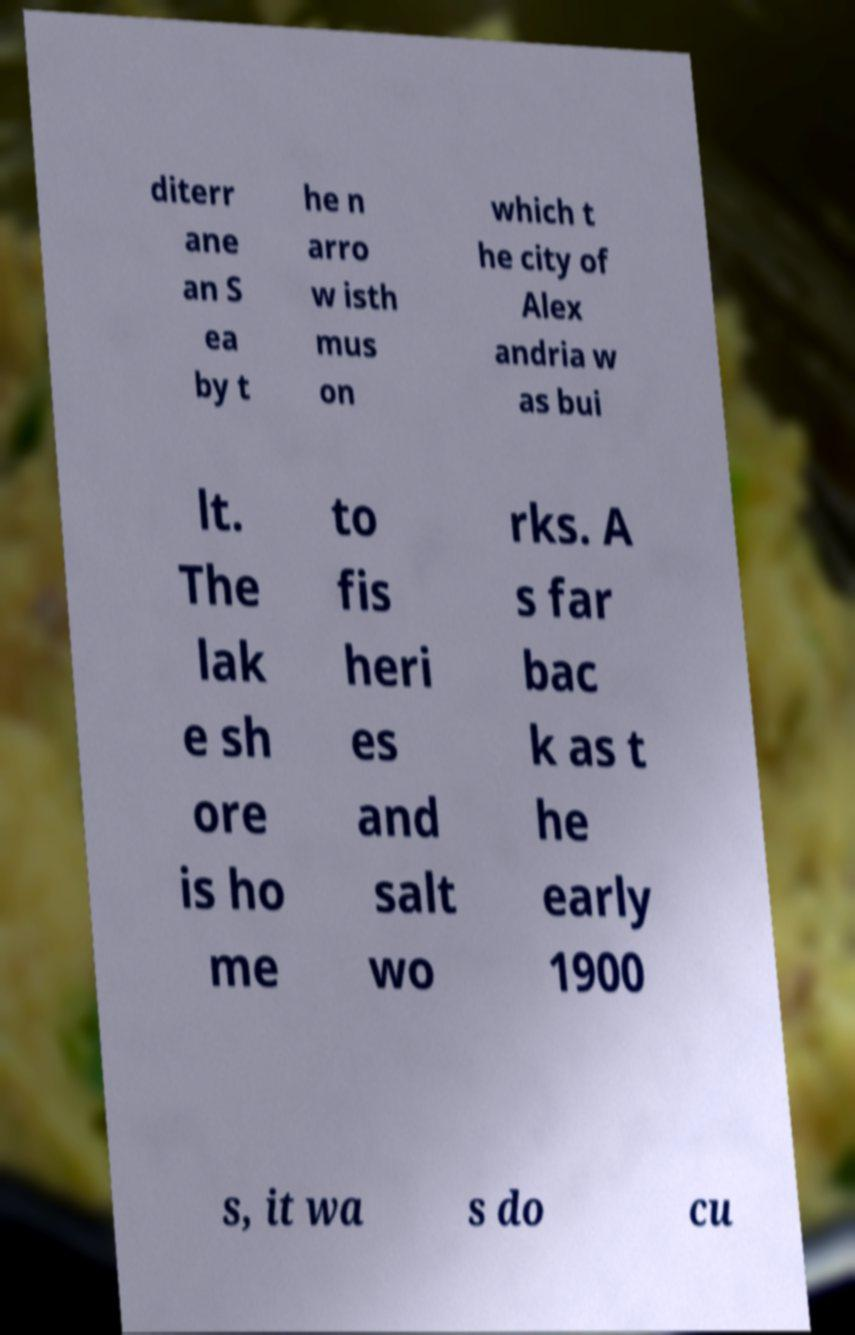Please identify and transcribe the text found in this image. diterr ane an S ea by t he n arro w isth mus on which t he city of Alex andria w as bui lt. The lak e sh ore is ho me to fis heri es and salt wo rks. A s far bac k as t he early 1900 s, it wa s do cu 